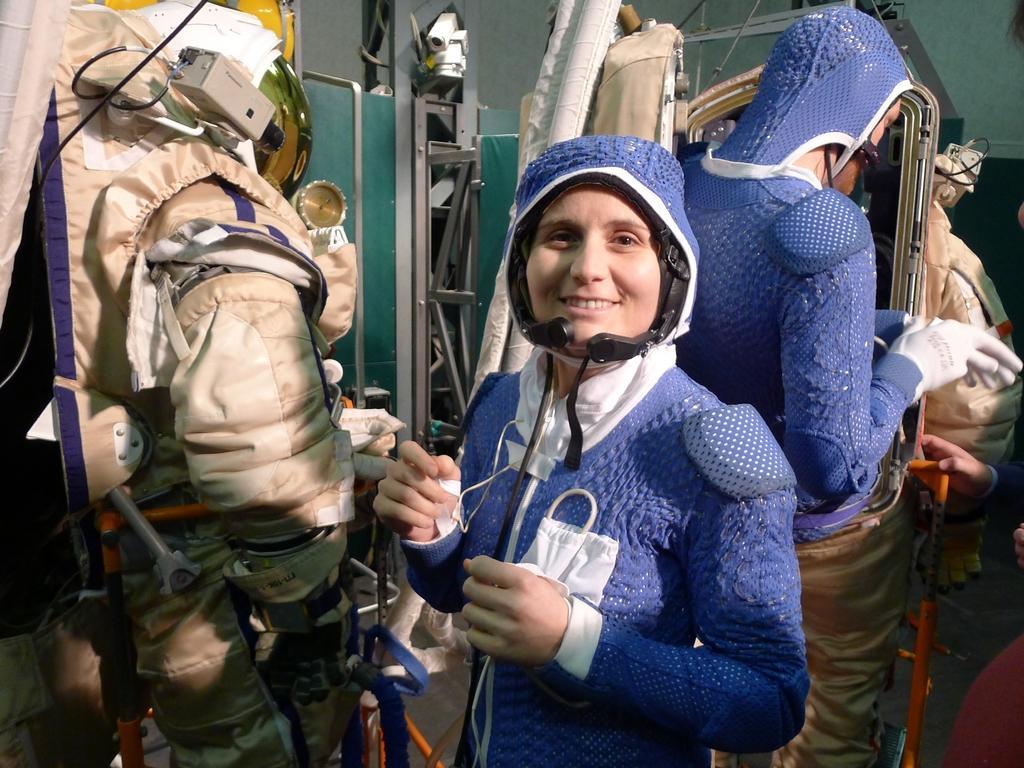How would you summarize this image in a sentence or two? In this image there is a girl in the middle who is wearing the helmet and a costume. Beside her there is a space jacket. On the left side top there is a video camera. On the right side there is another person who is standing by wearing the gloves. Beside him there is another person who is holding the sticks. In the background there are metal objects. 